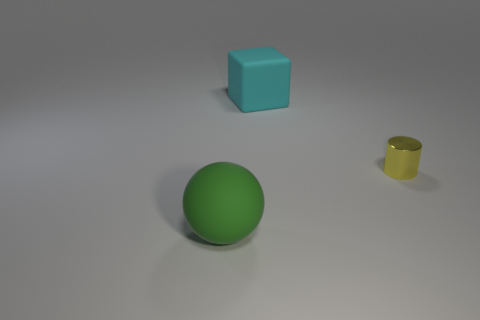Add 2 rubber spheres. How many objects exist? 5 Subtract all balls. How many objects are left? 2 Subtract 0 gray cylinders. How many objects are left? 3 Subtract 1 blocks. How many blocks are left? 0 Subtract all blue spheres. Subtract all brown cylinders. How many spheres are left? 1 Subtract all small green metal cylinders. Subtract all big matte balls. How many objects are left? 2 Add 3 green matte things. How many green matte things are left? 4 Add 3 big green things. How many big green things exist? 4 